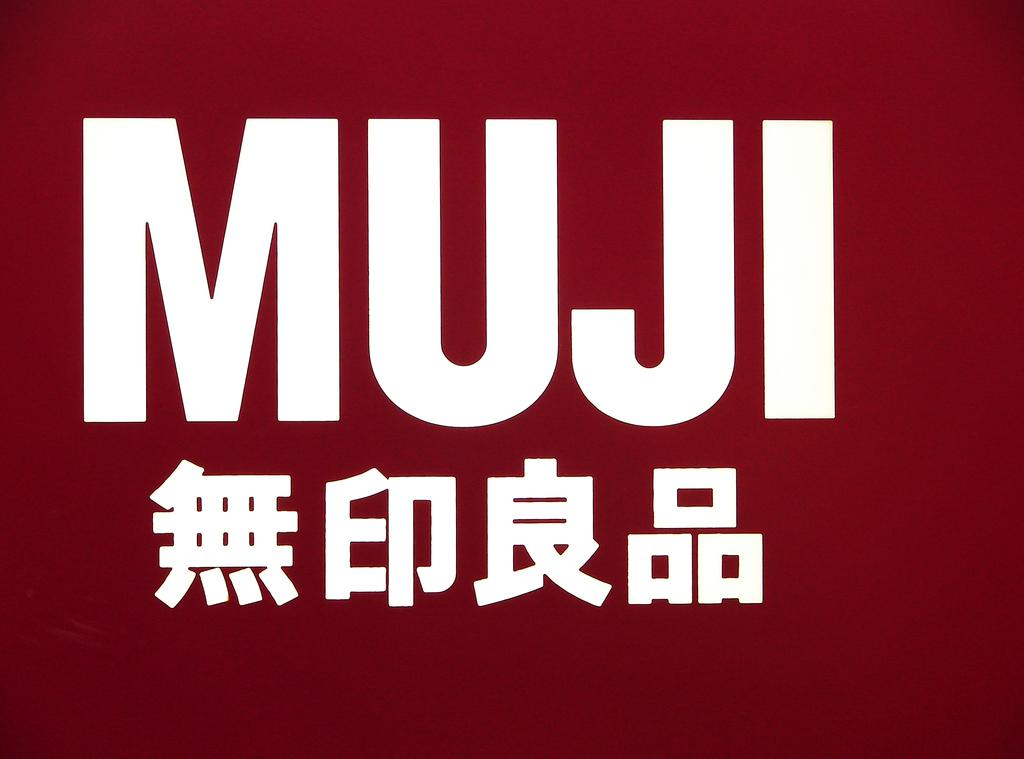<image>
Provide a brief description of the given image. A dark red sign that has MUJI inscribed in large white letters 